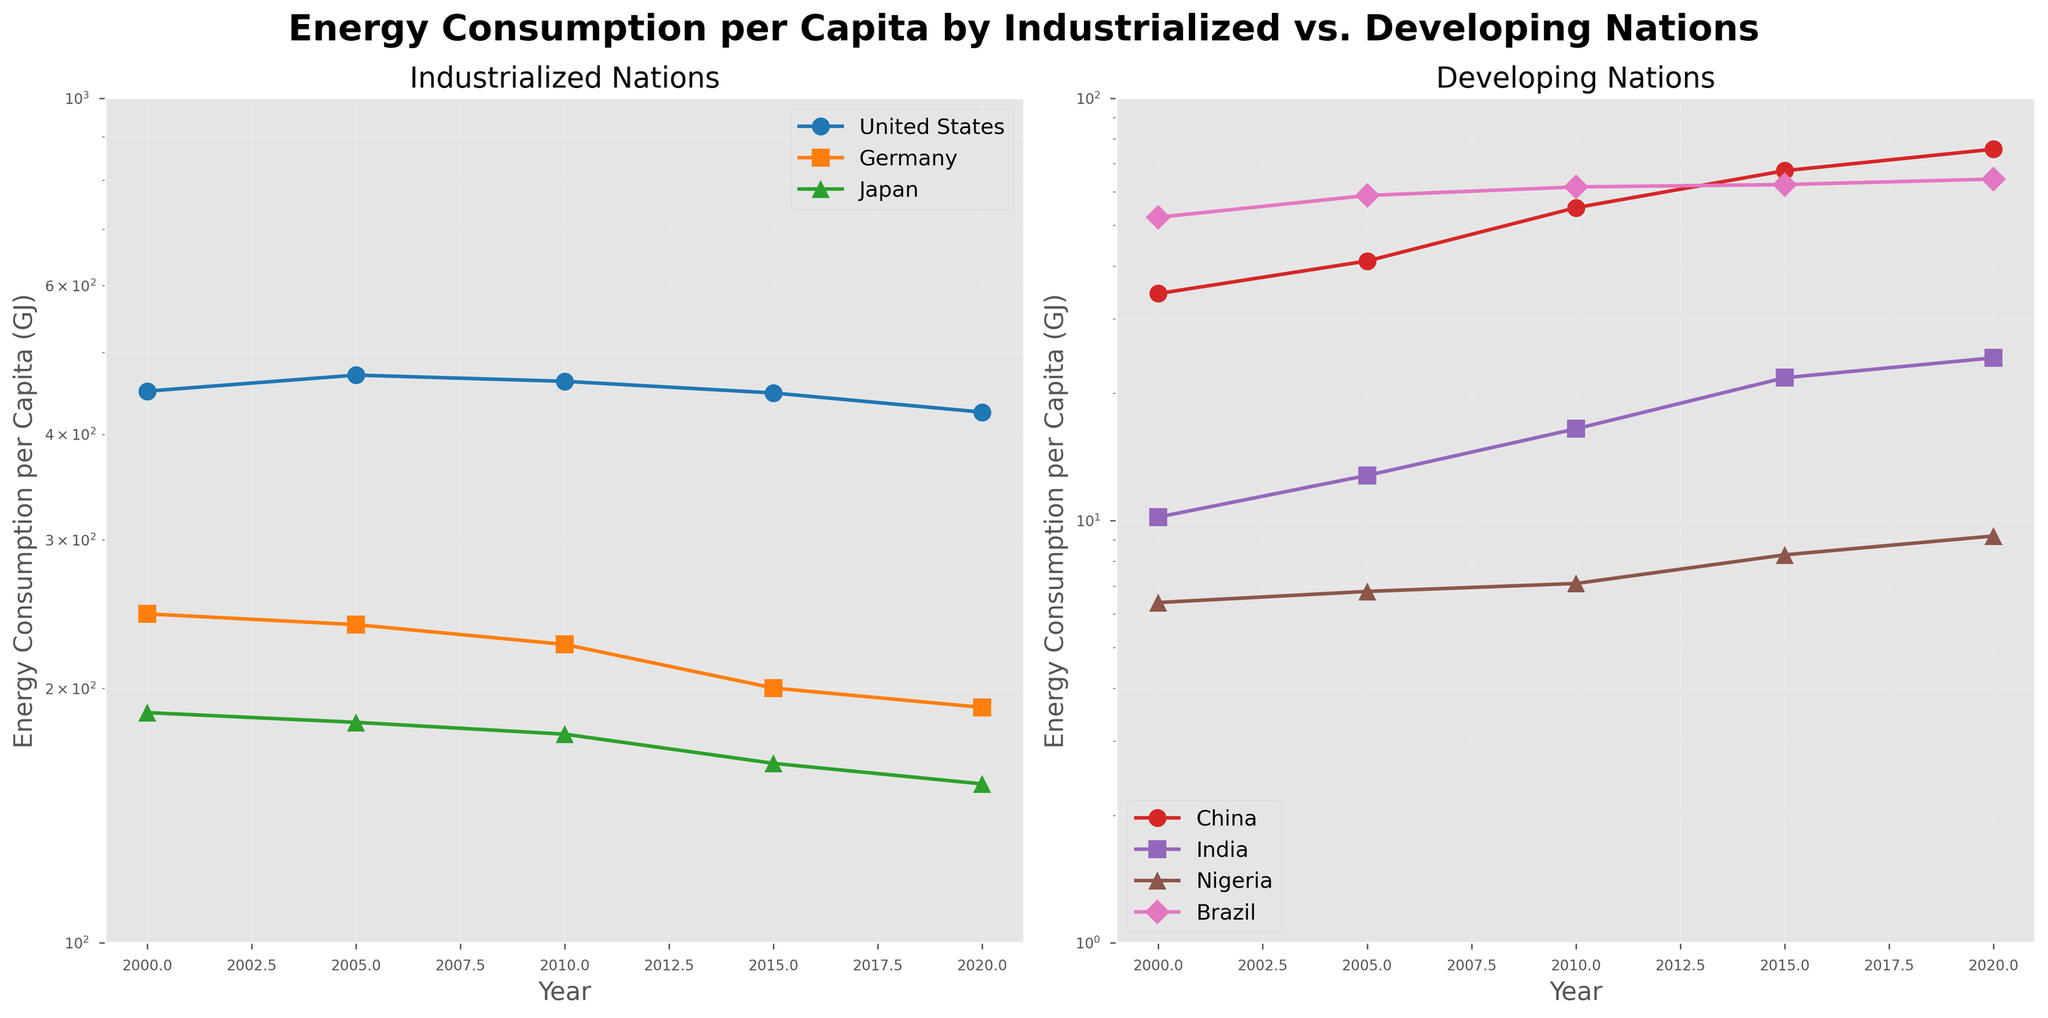What's the title of the figure? The title is located prominently at the top of the figure and states the main subject of the plot.
Answer: Energy Consumption per Capita by Industrialized vs. Developing Nations How many countries are shown in the subplot for Industrialized Nations? The subplot for Industrialized Nations has a legend listing the countries included. There are three countries listed.
Answer: 3 Which Industrialized Nation had the lowest energy consumption per capita in 2020? By examining the lines and markers for the year 2020 in the subplot for Industrialized Nations, we can see the values for each country. Japan's line is the lowest.
Answer: Japan Did any Developing Nation have an energy consumption per capita greater than or equal to 100 GJ at any point? The y-axis on the Developing Nations subplot is on a logarithmic scale, with the highest value at 100 GJ. No developing nation’s data line reaches or surpasses this mark.
Answer: No Which country among the Developing Nations showed the most significant increase in energy consumption per capita from 2000 to 2020? By comparing the starting and ending values of each line in the Developing Nations subplot, it is clear that China has the most significant increase.
Answer: China How does the energy consumption per capita of the United States in 2000 compare to Germany in 2020? Locate the 2000 marker for the US and the 2020 marker for Germany in the Industrialized Nations subplot. The US in 2000 is significantly higher than Germany in 2020.
Answer: Higher Which country among the Developing Nations had the smallest change in energy consumption per capita from 2000 to 2020? By visually comparing the slopes of each country's line in the Developing Nations subplot, Nigeria's line shows the least steep slope, indicating the smallest change.
Answer: Nigeria What is the general trend for energy consumption per capita among Industrialized Nations from 2000 to 2020? Look at the direction of the data lines for each country in the Industrialized Nations subplot. Most lines show a decline over this period.
Answer: Declining Is the trend for energy consumption per capita consistent among all Developing Nations from 2000 to 2020? By examining the direction of the data lines for each Developing Nation, it's noticeable that all lines generally trend upward, though the magnitudes differ.
Answer: Yes Which Developing Nation had an energy consumption per capita closest to Industrialized Nations' lower limit of 100 GJ? By looking at the end values of the data lines in the Developing Nations subplot, China's 2020 value is the closest to the 100 GJ mark, but still below it.
Answer: China 